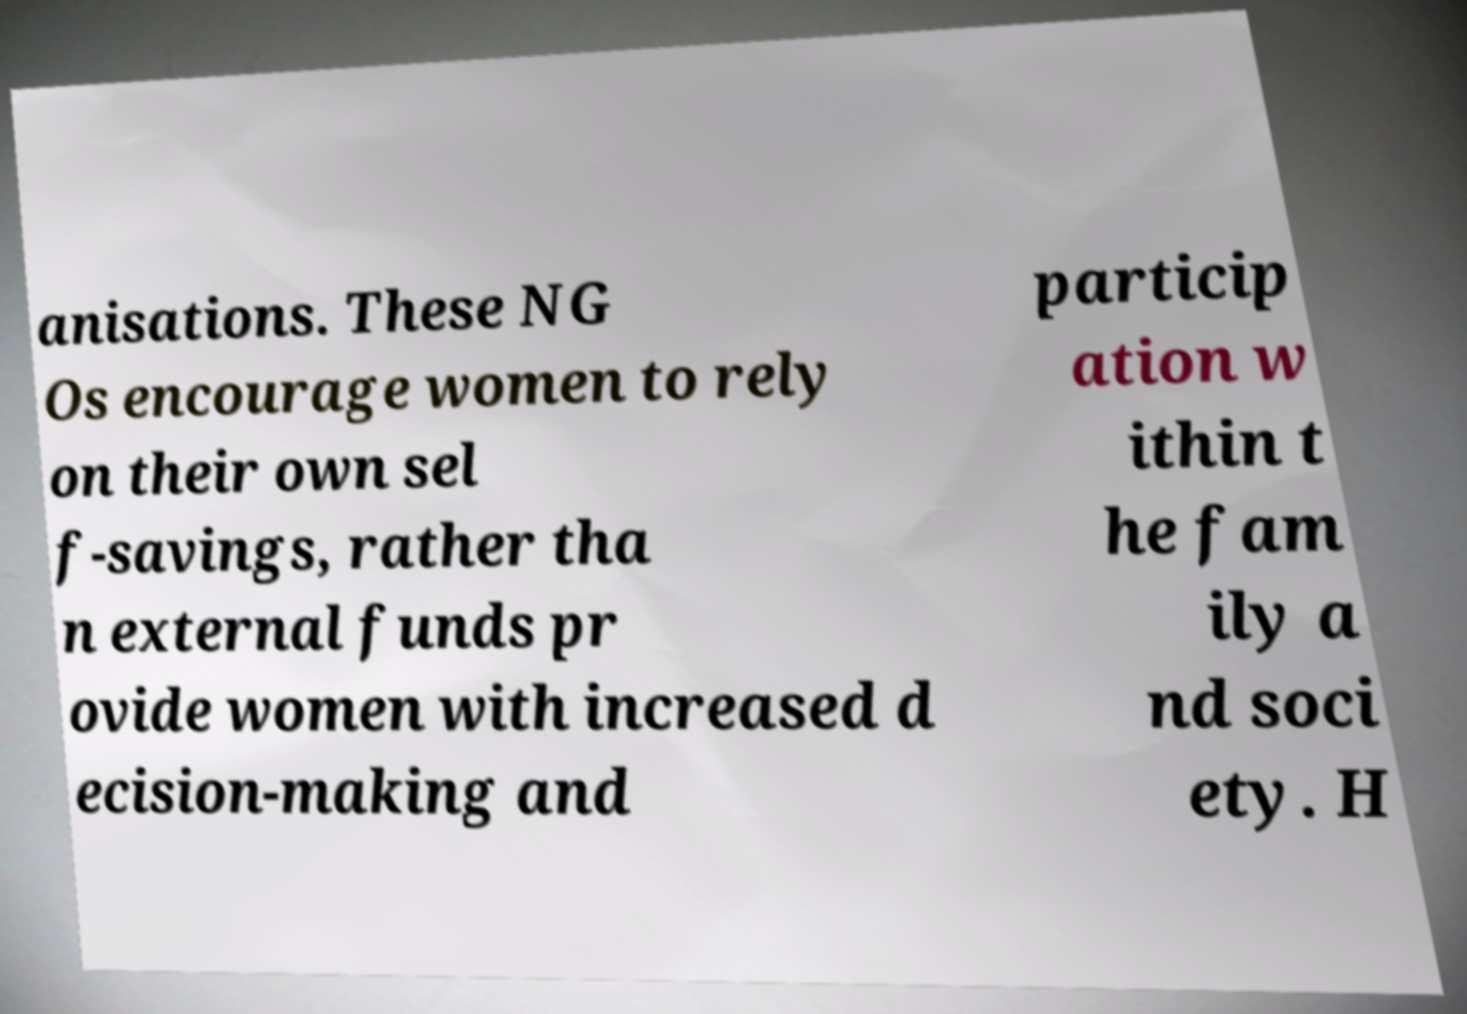Can you accurately transcribe the text from the provided image for me? anisations. These NG Os encourage women to rely on their own sel f-savings, rather tha n external funds pr ovide women with increased d ecision-making and particip ation w ithin t he fam ily a nd soci ety. H 